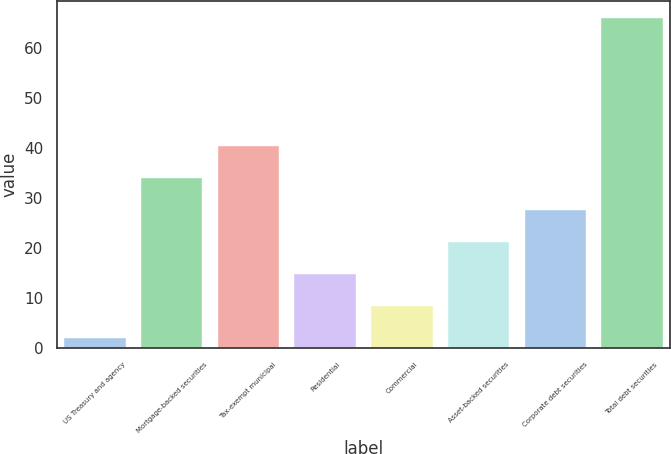<chart> <loc_0><loc_0><loc_500><loc_500><bar_chart><fcel>US Treasury and agency<fcel>Mortgage-backed securities<fcel>Tax-exempt municipal<fcel>Residential<fcel>Commercial<fcel>Asset-backed securities<fcel>Corporate debt securities<fcel>Total debt securities<nl><fcel>2<fcel>34<fcel>40.4<fcel>14.8<fcel>8.4<fcel>21.2<fcel>27.6<fcel>66<nl></chart> 